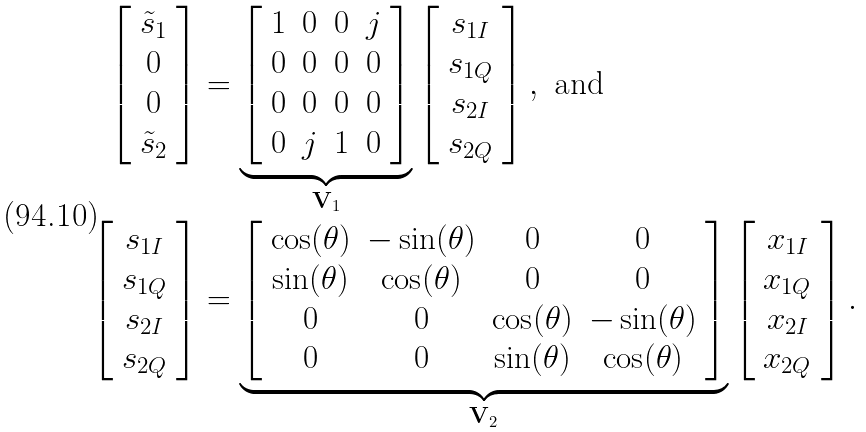<formula> <loc_0><loc_0><loc_500><loc_500>\left [ \begin{array} { c } { \tilde { s } _ { 1 } } \\ 0 \\ 0 \\ { \tilde { s } _ { 2 } } \end{array} \right ] & = \underbrace { \left [ \begin{array} { c c c c } 1 & 0 & 0 & j \\ 0 & 0 & 0 & 0 \\ 0 & 0 & 0 & 0 \\ 0 & j & 1 & 0 \end{array} \right ] } _ { { \mathbf V } _ { 1 } } \left [ \begin{array} { c } s _ { 1 I } \\ s _ { 1 Q } \\ s _ { 2 I } \\ s _ { 2 Q } \end{array} \right ] , \text { and} \\ \left [ \begin{array} { c } s _ { 1 I } \\ s _ { 1 Q } \\ s _ { 2 I } \\ s _ { 2 Q } \end{array} \right ] & = \underbrace { \left [ \begin{array} { c c c c } \cos ( \theta ) & - \sin ( \theta ) & 0 & 0 \\ \sin ( \theta ) & \cos ( \theta ) & 0 & 0 \\ 0 & 0 & \cos ( \theta ) & - \sin ( \theta ) \\ 0 & 0 & \sin ( \theta ) & \cos ( \theta ) \end{array} \right ] } _ { { \mathbf V } _ { 2 } } \left [ \begin{array} { c } x _ { 1 I } \\ x _ { 1 Q } \\ x _ { 2 I } \\ x _ { 2 Q } \end{array} \right ] .</formula> 